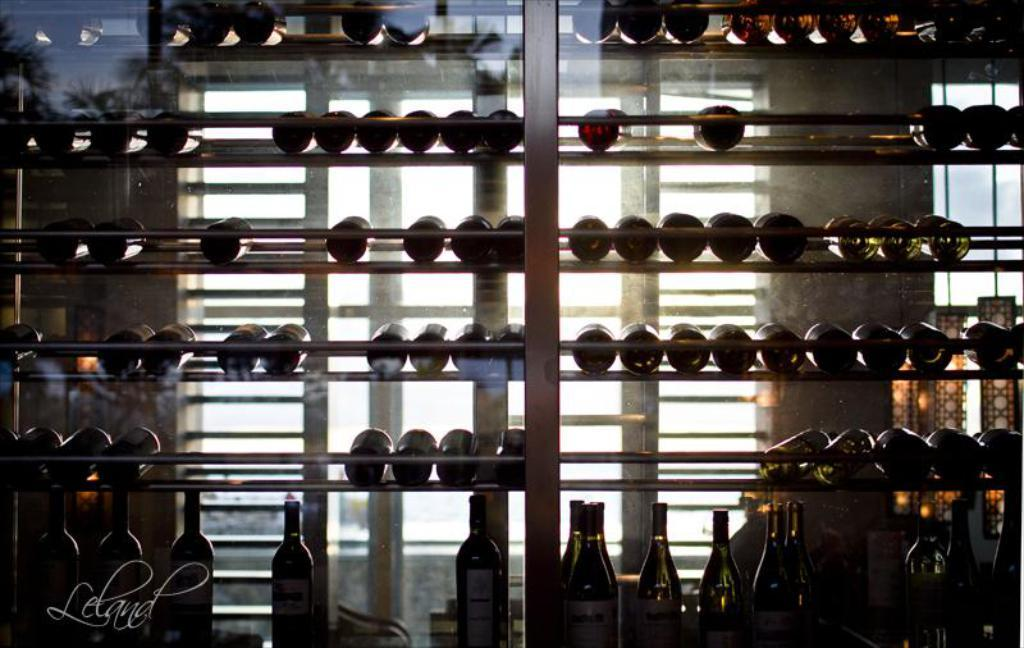What objects are on the racks in the image? There are bottles on the racks in the image. What can be found at the bottom of the image? There is text at the bottom of the image. Can you describe the window in the image? There is a window with grills behind the rack in the image. How many feathers can be seen floating near the bottles in the image? There are no feathers visible in the image; it only features bottles on racks, text at the bottom, and a window with grills. 